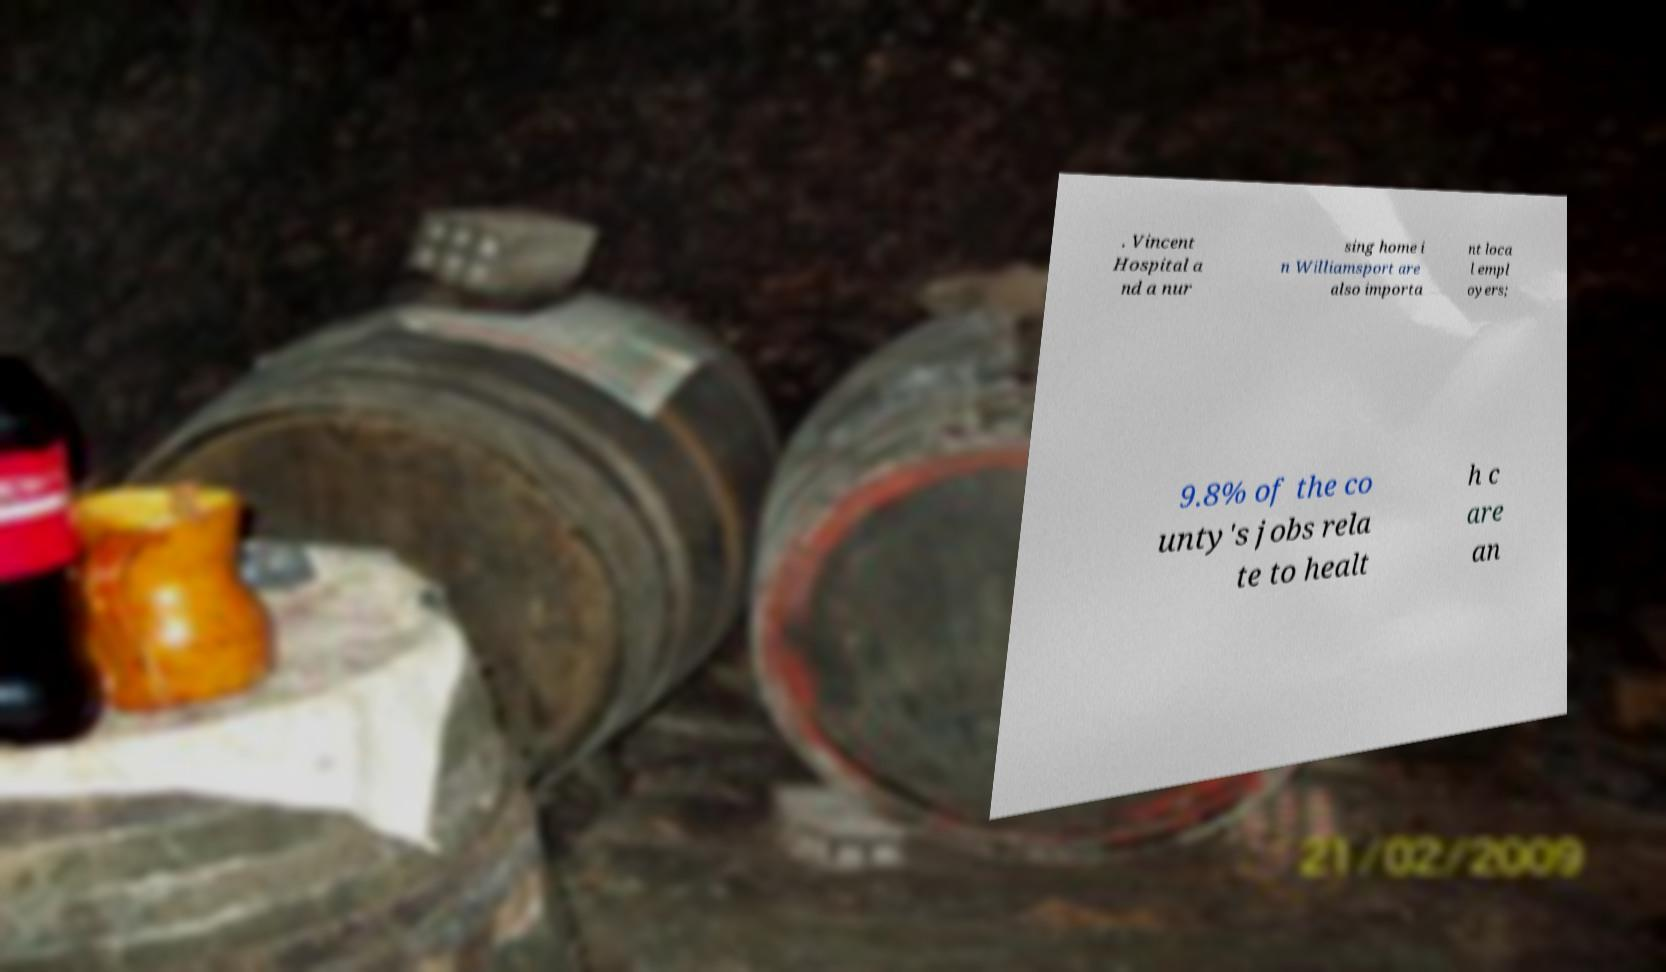Please read and relay the text visible in this image. What does it say? . Vincent Hospital a nd a nur sing home i n Williamsport are also importa nt loca l empl oyers; 9.8% of the co unty's jobs rela te to healt h c are an 